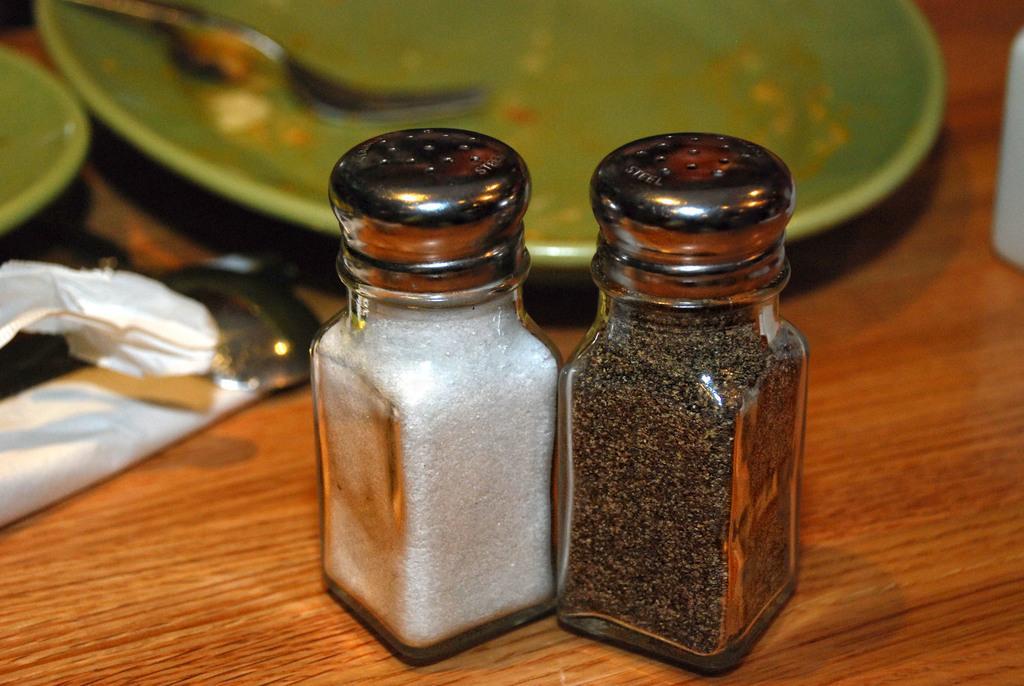Please provide a concise description of this image. In this image we can see the plates, jars, fork and some other objects on the table. 